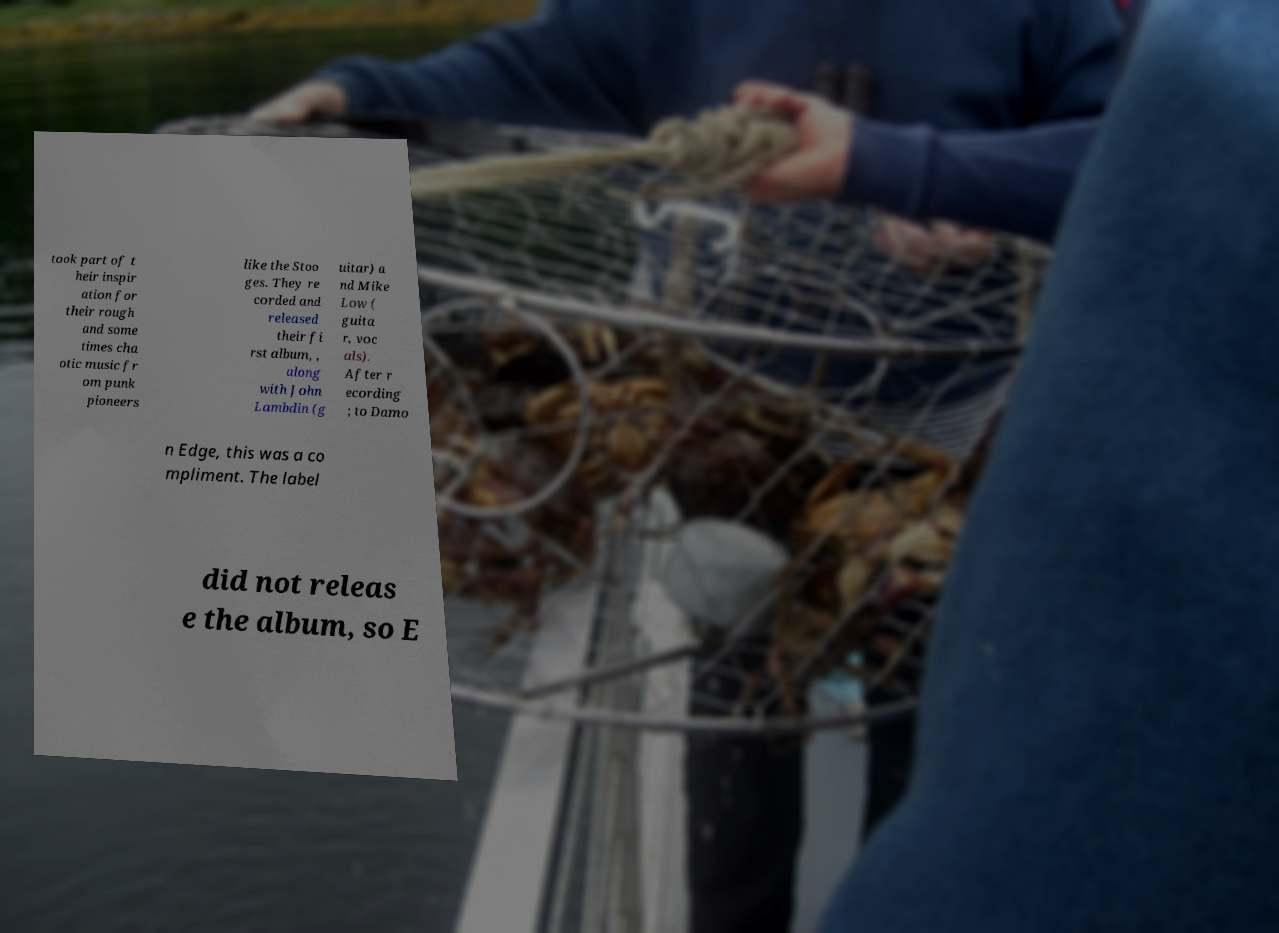What messages or text are displayed in this image? I need them in a readable, typed format. took part of t heir inspir ation for their rough and some times cha otic music fr om punk pioneers like the Stoo ges. They re corded and released their fi rst album, , along with John Lambdin (g uitar) a nd Mike Low ( guita r, voc als). After r ecording ; to Damo n Edge, this was a co mpliment. The label did not releas e the album, so E 